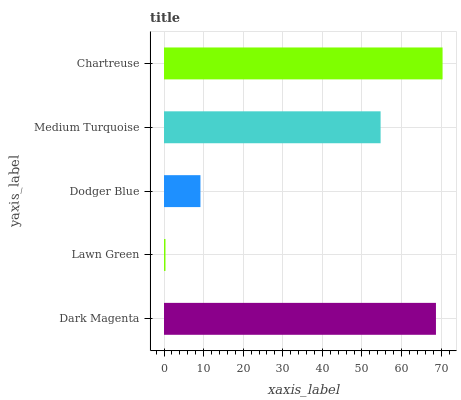Is Lawn Green the minimum?
Answer yes or no. Yes. Is Chartreuse the maximum?
Answer yes or no. Yes. Is Dodger Blue the minimum?
Answer yes or no. No. Is Dodger Blue the maximum?
Answer yes or no. No. Is Dodger Blue greater than Lawn Green?
Answer yes or no. Yes. Is Lawn Green less than Dodger Blue?
Answer yes or no. Yes. Is Lawn Green greater than Dodger Blue?
Answer yes or no. No. Is Dodger Blue less than Lawn Green?
Answer yes or no. No. Is Medium Turquoise the high median?
Answer yes or no. Yes. Is Medium Turquoise the low median?
Answer yes or no. Yes. Is Chartreuse the high median?
Answer yes or no. No. Is Dodger Blue the low median?
Answer yes or no. No. 